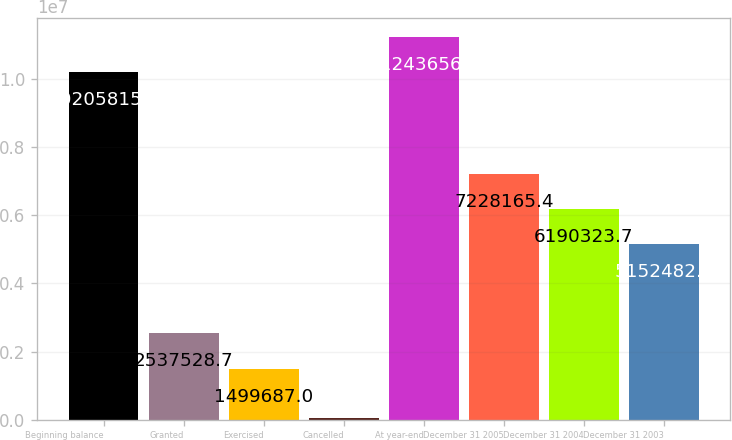<chart> <loc_0><loc_0><loc_500><loc_500><bar_chart><fcel>Beginning balance<fcel>Granted<fcel>Exercised<fcel>Cancelled<fcel>At year-end<fcel>December 31 2005<fcel>December 31 2004<fcel>December 31 2003<nl><fcel>1.02058e+07<fcel>2.53753e+06<fcel>1.49969e+06<fcel>57706<fcel>1.12437e+07<fcel>7.22817e+06<fcel>6.19032e+06<fcel>5.15248e+06<nl></chart> 